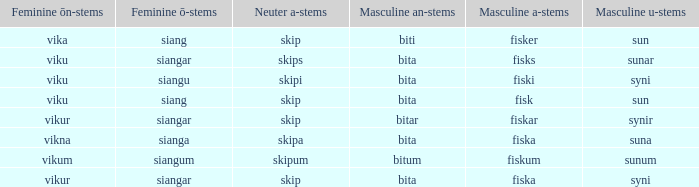What is the an-stem for the word which has an ö-stems of siangar and an u-stem ending of syni? Bita. Help me parse the entirety of this table. {'header': ['Feminine ōn-stems', 'Feminine ō-stems', 'Neuter a-stems', 'Masculine an-stems', 'Masculine a-stems', 'Masculine u-stems'], 'rows': [['vika', 'siang', 'skip', 'biti', 'fisker', 'sun'], ['viku', 'siangar', 'skips', 'bita', 'fisks', 'sunar'], ['viku', 'siangu', 'skipi', 'bita', 'fiski', 'syni'], ['viku', 'siang', 'skip', 'bita', 'fisk', 'sun'], ['vikur', 'siangar', 'skip', 'bitar', 'fiskar', 'synir'], ['vikna', 'sianga', 'skipa', 'bita', 'fiska', 'suna'], ['vikum', 'siangum', 'skipum', 'bitum', 'fiskum', 'sunum'], ['vikur', 'siangar', 'skip', 'bita', 'fiska', 'syni']]} 